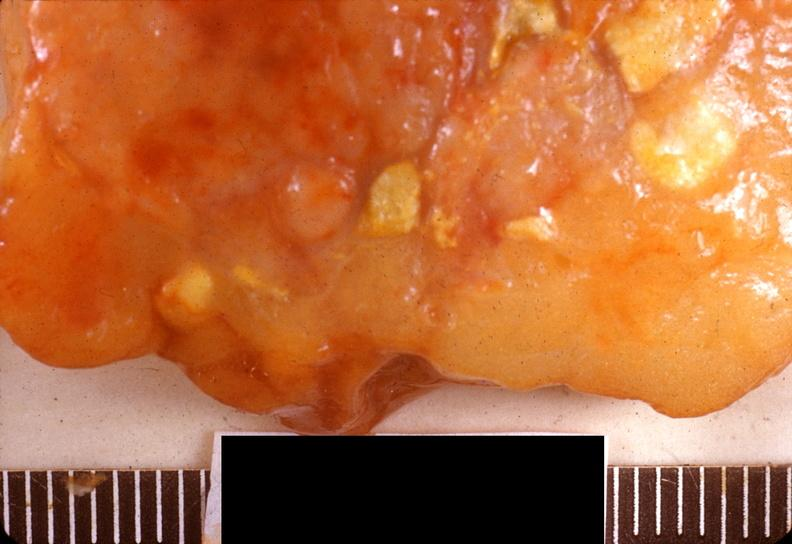does this image show acute pancreatitis?
Answer the question using a single word or phrase. Yes 